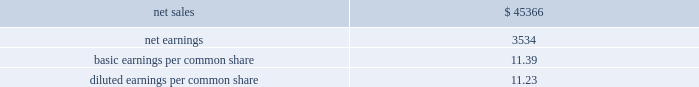Supplemental pro forma financial information ( unaudited ) the table presents summarized unaudited pro forma financial information as if sikorsky had been included in our financial results for the entire year in 2015 ( in millions ) : .
The unaudited supplemental pro forma financial data above has been calculated after applying our accounting policies and adjusting the historical results of sikorskywith pro forma adjustments , net of tax , that assume the acquisition occurred on january 1 , 2015 .
Significant pro forma adjustments include the recognition of additional amortization expense related to acquired intangible assets and additional interest expense related to the short-term debt used to finance the acquisition .
These adjustments assume the application of fair value adjustments to intangibles and the debt issuance occurred on january 1 , 2015 and are approximated as follows : amortization expense of $ 125million and interest expense of $ 40million .
In addition , significant nonrecurring adjustments include the elimination of a $ 72million pension curtailment loss , net of tax , recognized in 2015 and the elimination of a $ 58 million income tax charge related to historic earnings of foreign subsidiaries recognized by sikorsky in 2015 .
The unaudited supplemental pro forma financial information also reflects an increase in interest expense , net of tax , of approximately $ 110 million in 2015 .
The increase in interest expense is the result of assuming the november 2015 notes were issued on january 1 , 2015 .
Proceeds of the november 2015 notes were used to repay all outstanding borrowings under the 364- day facility used to finance a portion of the purchase price of sikorsky , as contemplated at the date of acquisition .
The unaudited supplemental pro forma financial information does not reflect the realization of any expected ongoing cost or revenue synergies relating to the integration of the two companies .
Further , the pro forma data should not be considered indicative of the results that would have occurred if the acquisition , related financing and associated notes issuance and repayment of the 364-day facility had been consummated on january 1 , 2015 , nor are they indicative of future results .
Consolidation of awemanagement limited on august 24 , 2016 , we increased our ownership interest in the awe joint venture , which operates the united kingdom 2019s nuclear deterrent program , from 33% ( 33 % ) to 51% ( 51 % ) .
At which time , we began consolidating awe .
Consequently , our operating results include 100% ( 100 % ) of awe 2019s sales and 51% ( 51 % ) of its operating profit .
Prior to increasing our ownership interest , we accounted for our investment inawe using the equity method of accounting .
Under the equity method , we recognized only 33% ( 33 % ) ofawe 2019s earnings or losses and no sales.accordingly , prior toaugust 24 , 2016 , the date we obtained control , we recorded 33%ofawe 2019s net earnings in our operating results and subsequent to august 24 , 2016 , we recognized 100% ( 100 % ) of awe 2019s sales and 51% ( 51 % ) of its operating profit .
We accounted for this transaction as a 201cstep acquisition 201d ( as defined by u.s .
Gaap ) , which requires us to consolidate and record the assets and liabilities ofawe at fair value.accordingly , we recorded intangible assets of $ 243million related to customer relationships , $ 32 million of net liabilities , and noncontrolling interests of $ 107 million .
The intangible assets are being amortized over a period of eight years in accordance with the underlying pattern of economic benefit reflected by the future net cash flows .
In 2016we recognized a non-cash net gain of $ 104million associatedwith obtaining a controlling interest inawewhich consisted of a $ 127 million pretax gain recognized in the operating results of our space business segment and $ 23 million of tax-related items at our corporate office .
The gain represents the fair value of our 51% ( 51 % ) interest inawe , less the carrying value of our previously held investment inawe and deferred taxes .
The gainwas recorded in other income , net on our consolidated statements of earnings .
The fair value ofawe ( including the intangible assets ) , our controlling interest , and the noncontrolling interests were determined using the income approach .
Divestiture of the information systems & global solutions business onaugust 16 , 2016wedivested our former is&gsbusinesswhichmergedwithleidos , in areversemorristrust transactionrr ( the 201ctransaction 201d ) .
The transaction was completed in a multi-step process pursuant to which we initially contributed the is&gs business to abacus innovations corporation ( abacus ) , a wholly owned subsidiary of lockheed martin created to facilitate the transaction , and the common stock ofabacus was distributed to participating lockheedmartin stockholders through an exchange offer .
Under the terms of the exchange offer , lockheedmartin stockholders had the option to exchange shares of lockheedmartin common stock for shares of abacus common stock .
At the conclusion of the exchange offer , all shares of abacus common stock were exchanged for 9369694 shares of lockheed martin common stock held by lockheed martin stockholders that elected to participate in the exchange.the shares of lockheedmartin common stock thatwere exchanged and acceptedwere retired , reducing the number of shares of our common stock outstanding by approximately 3% ( 3 % ) .
Following the exchange offer , abacus merged with .
What was the profit margin? 
Computations: (3534 / 45366)
Answer: 0.0779. 